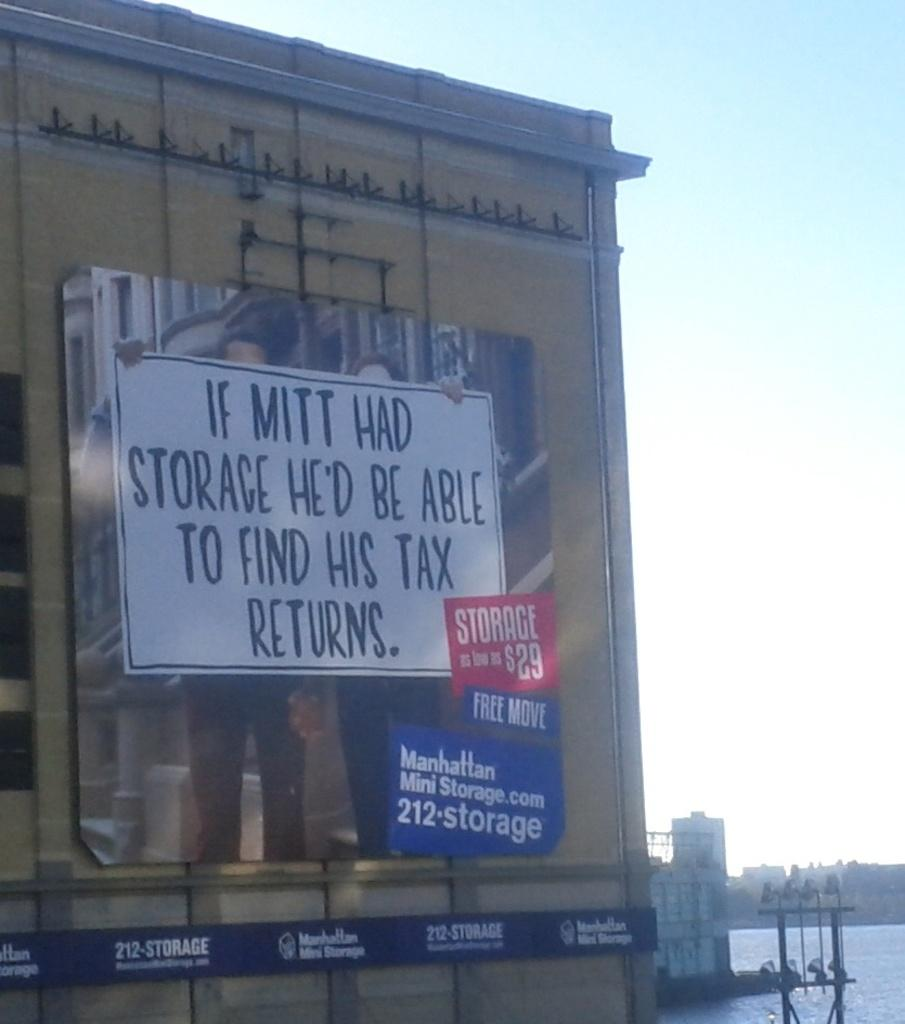<image>
Create a compact narrative representing the image presented. A large sign that says "If mitt had storage he'd be able to find his tax returns" 